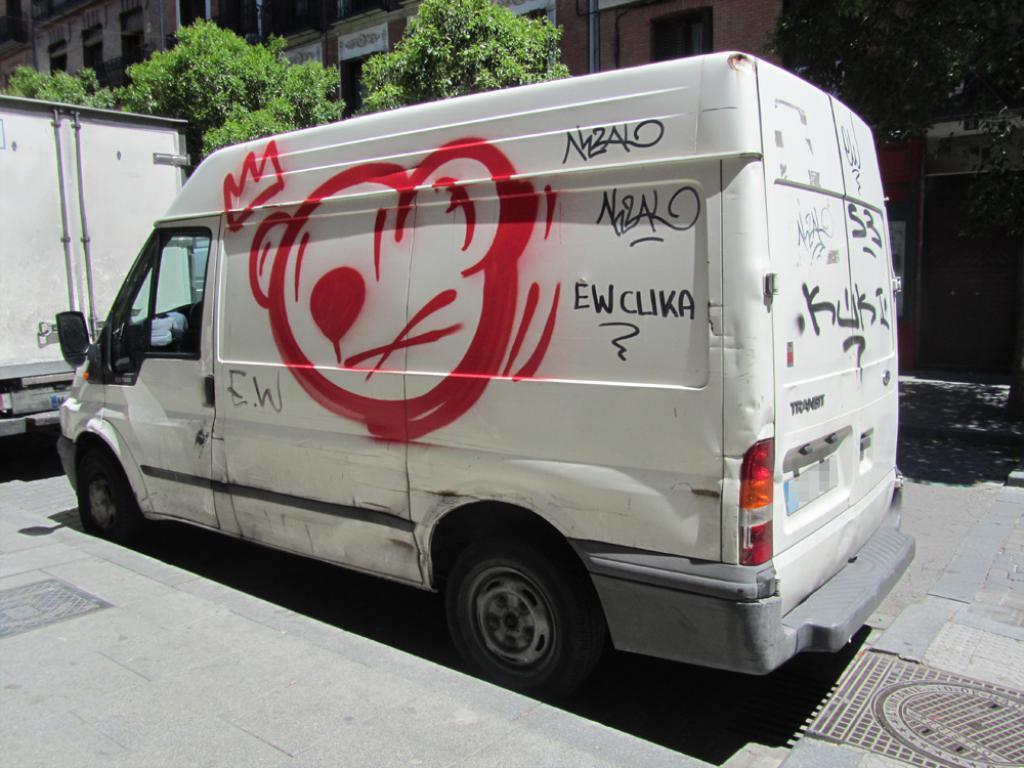Please provide a concise description of this image. In the center of the image we can see vehicles on the road. In the background we can see trees and buildings. 